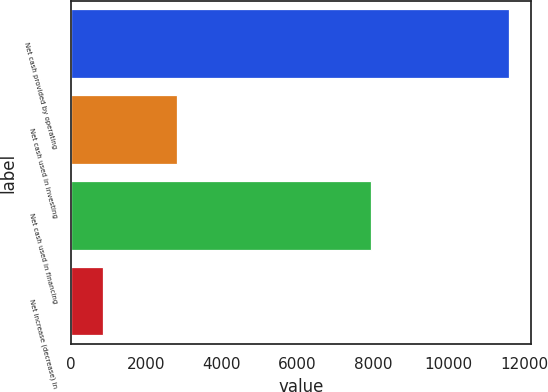Convert chart. <chart><loc_0><loc_0><loc_500><loc_500><bar_chart><fcel>Net cash provided by operating<fcel>Net cash used in investing<fcel>Net cash used in financing<fcel>Net increase (decrease) in<nl><fcel>11608<fcel>2803<fcel>7943<fcel>862<nl></chart> 